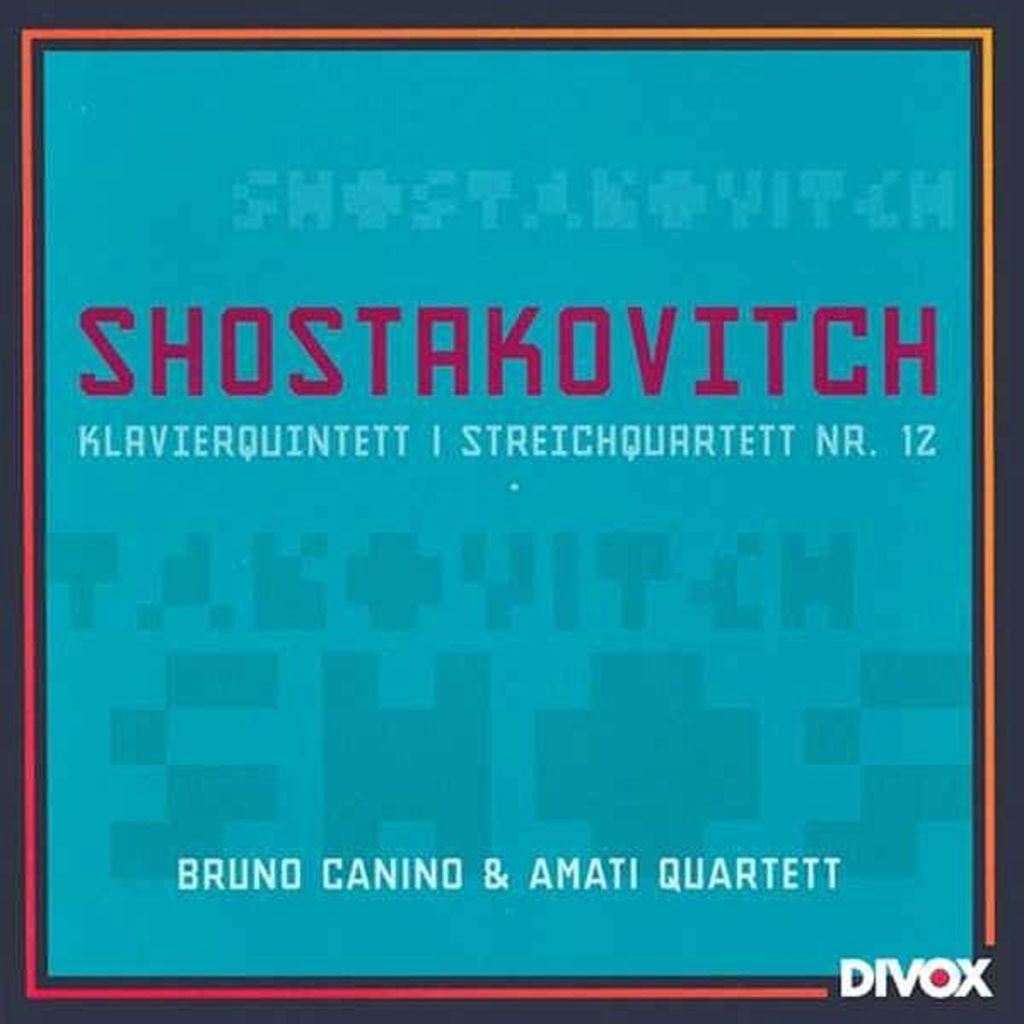Provide a one-sentence caption for the provided image. A poster with a blue background with the heading Shostakovitch. 